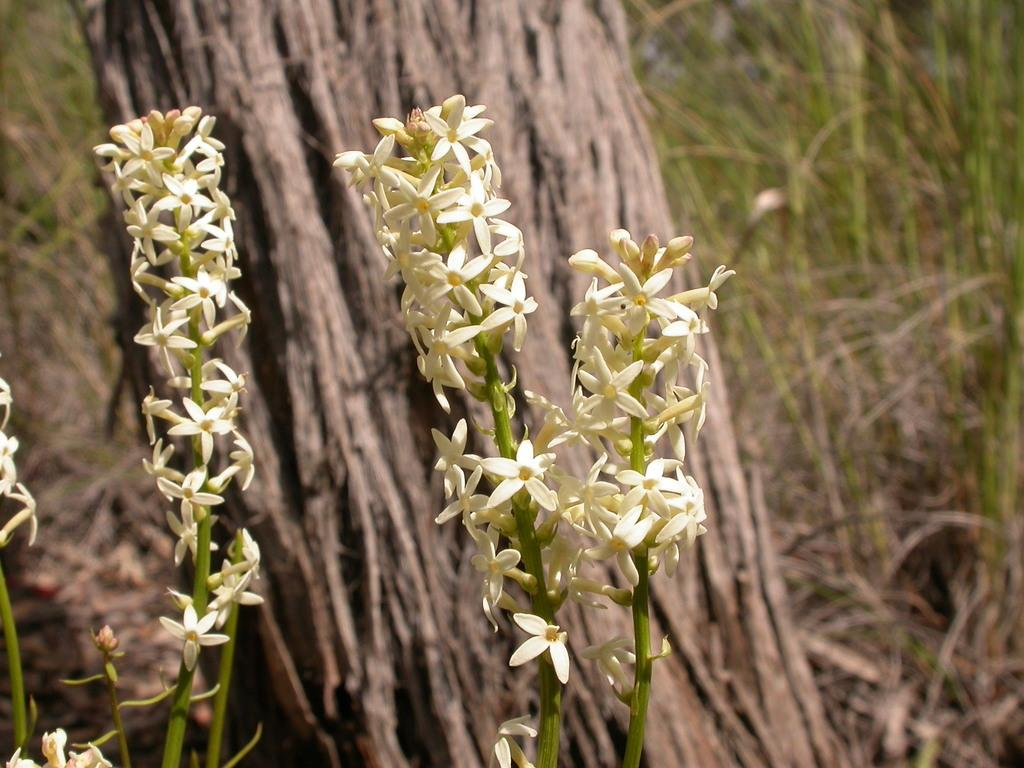What type of vegetation can be seen in the image? There are flowering plants and grass in the image. What else is present in the image besides vegetation? There is a tree trunk in the image. Can you tell if the image was taken during the day or night? The image was likely taken during the day, as there is no indication of darkness or artificial lighting. What type of paper can be seen hanging on the wall in the image? There is no paper visible in the image; it primarily features vegetation and a tree trunk. Can you hear the wren singing in the image? There is no audio associated with the image, and no wren is visible, so it is not possible to determine if a wren is singing. 